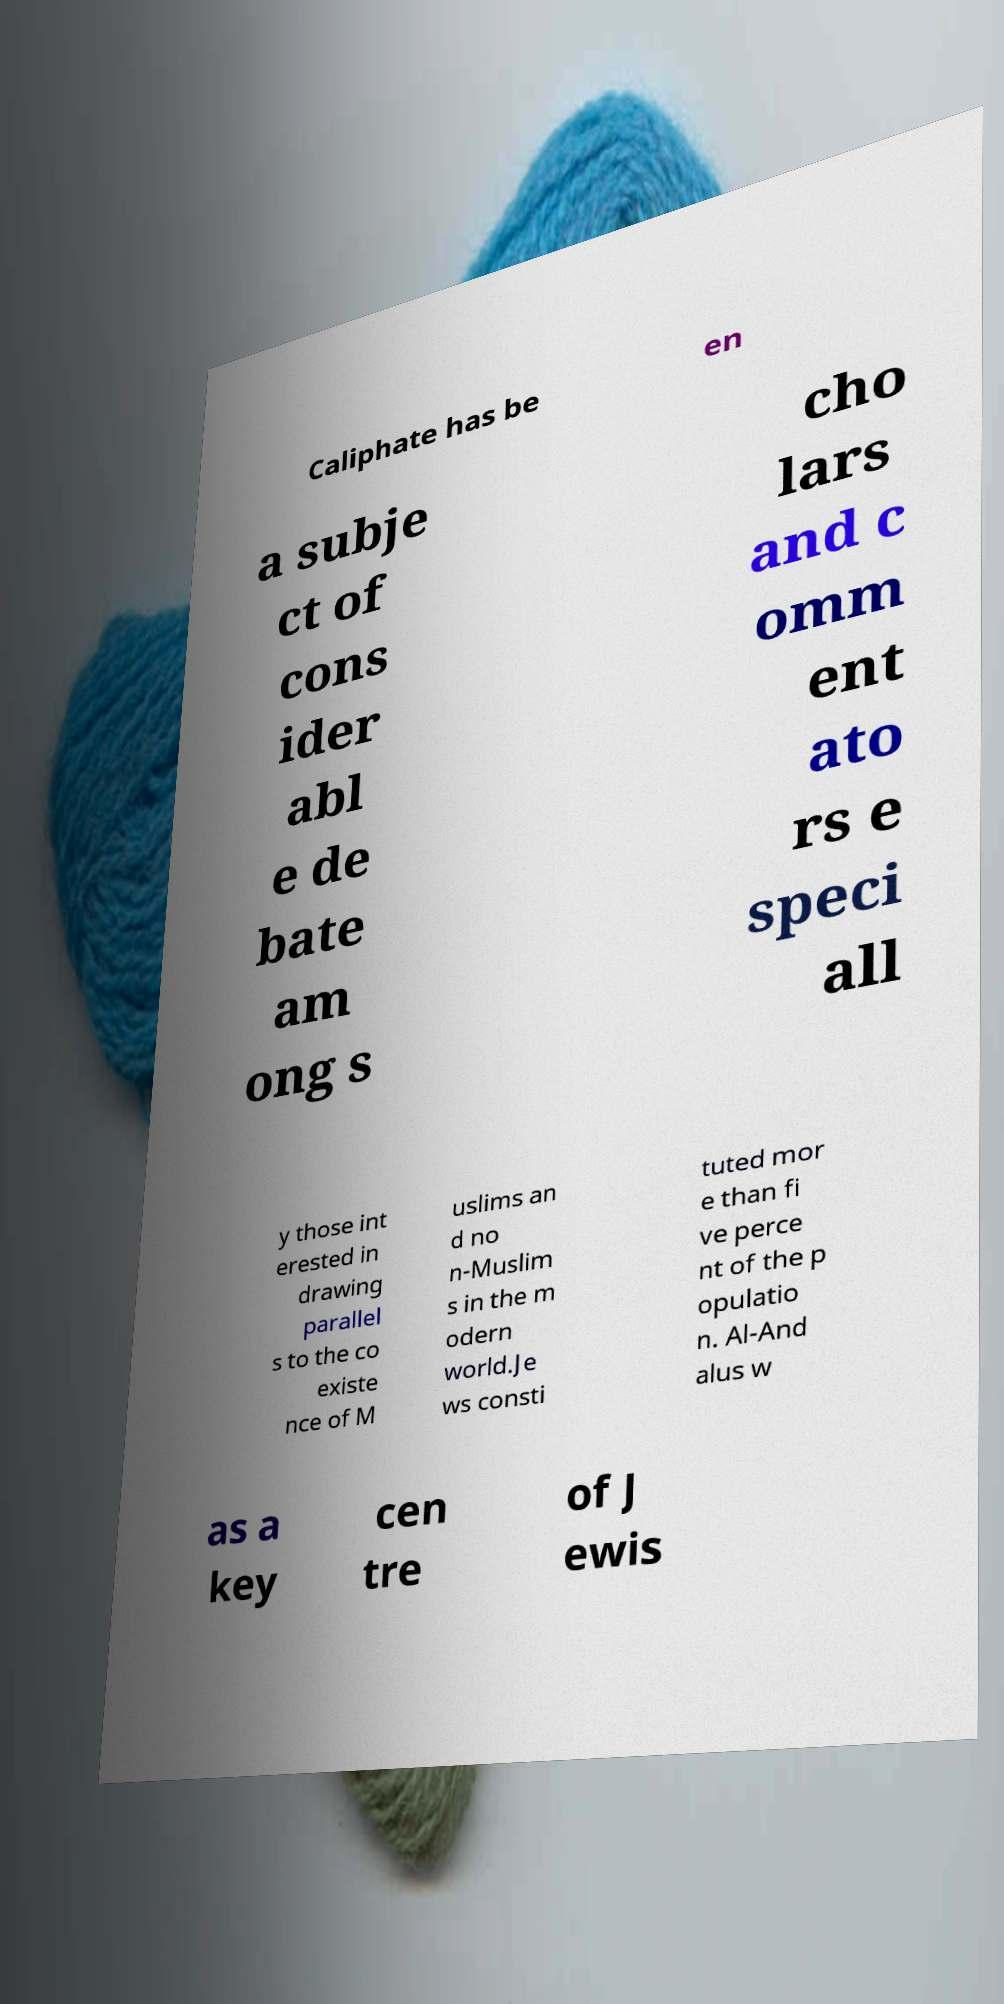I need the written content from this picture converted into text. Can you do that? Caliphate has be en a subje ct of cons ider abl e de bate am ong s cho lars and c omm ent ato rs e speci all y those int erested in drawing parallel s to the co existe nce of M uslims an d no n-Muslim s in the m odern world.Je ws consti tuted mor e than fi ve perce nt of the p opulatio n. Al-And alus w as a key cen tre of J ewis 